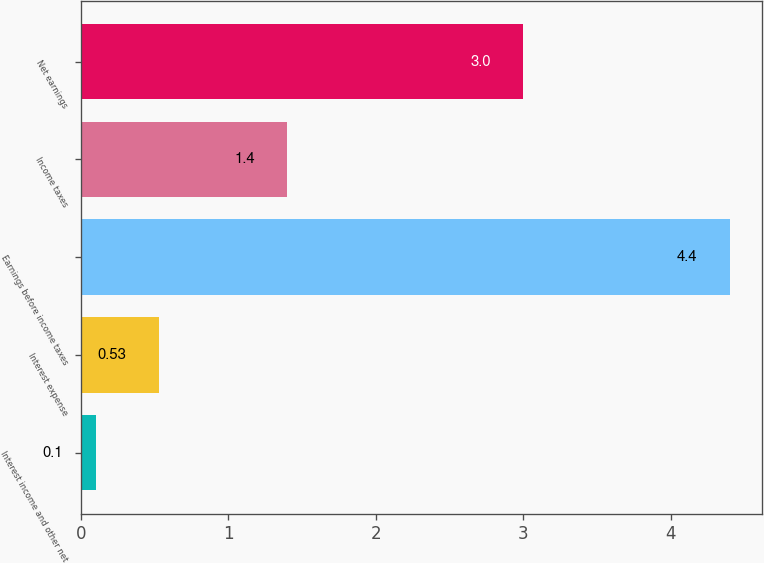<chart> <loc_0><loc_0><loc_500><loc_500><bar_chart><fcel>Interest income and other net<fcel>Interest expense<fcel>Earnings before income taxes<fcel>Income taxes<fcel>Net earnings<nl><fcel>0.1<fcel>0.53<fcel>4.4<fcel>1.4<fcel>3<nl></chart> 